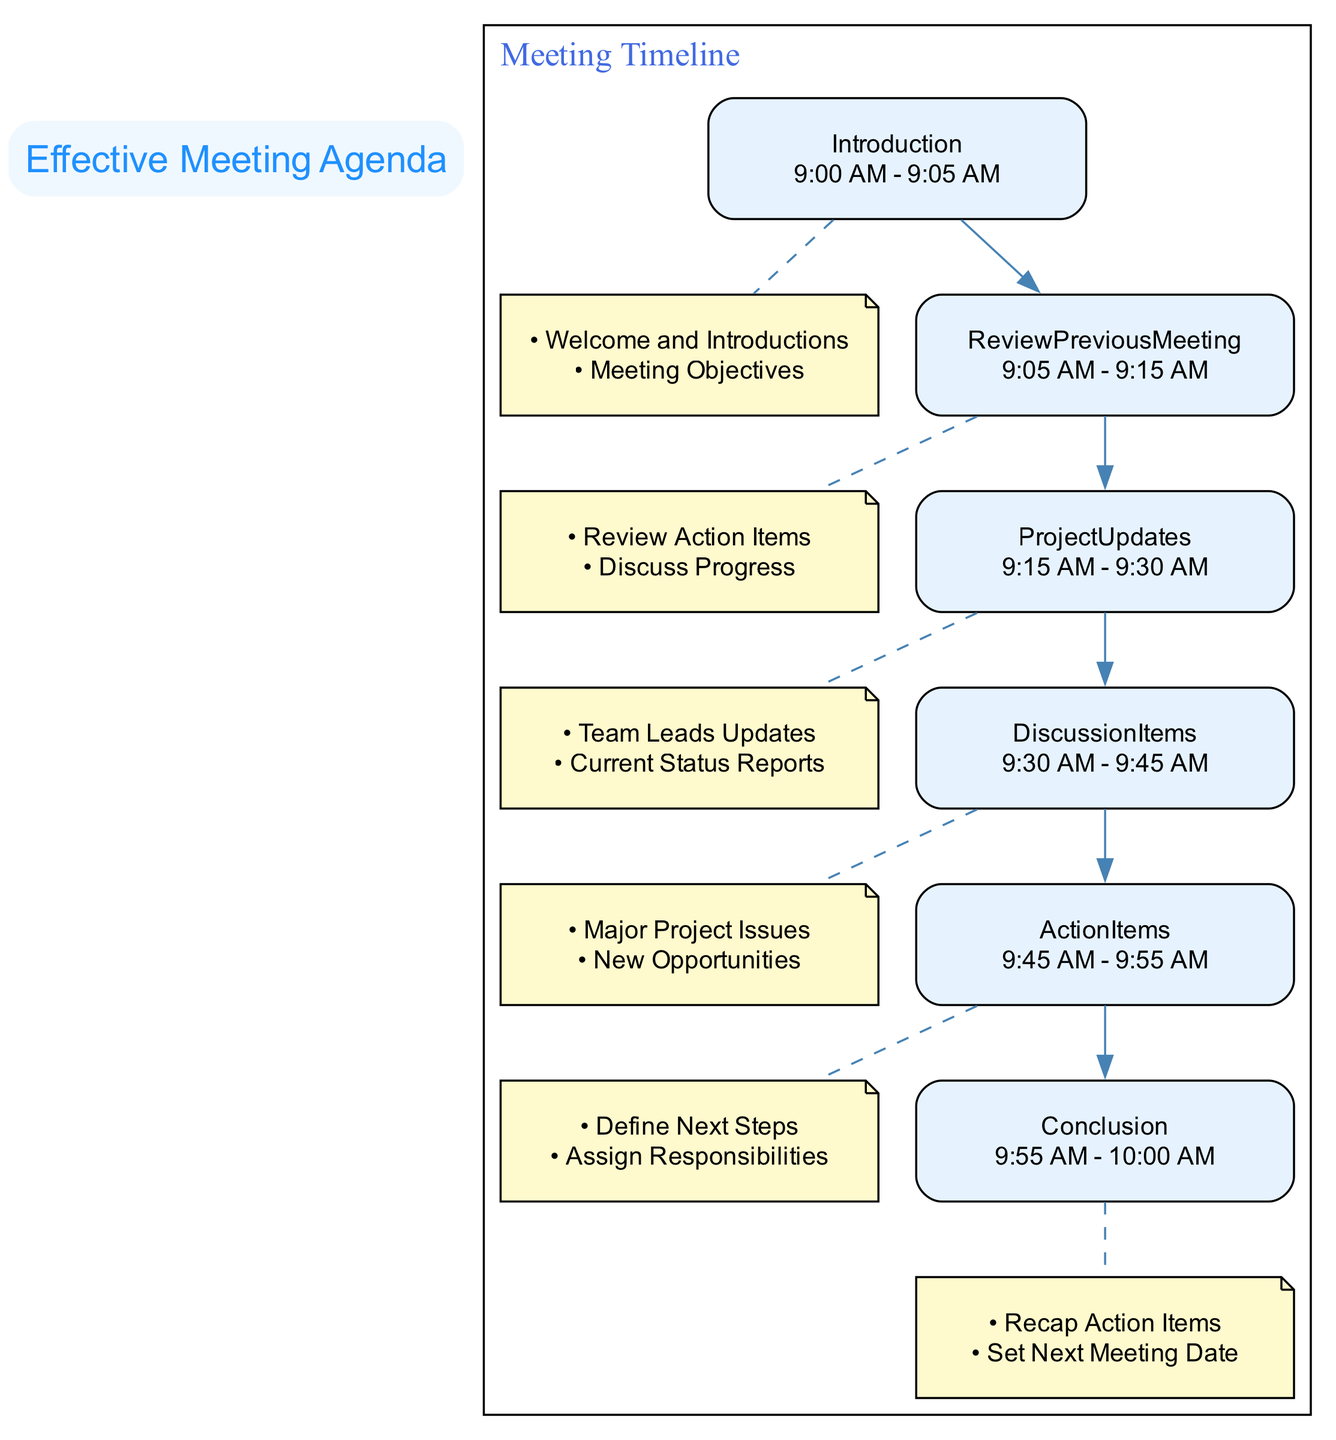What is the total duration of the meeting? The meeting starts at 9:00 AM and ends at 10:00 AM, giving a total duration of 1 hour.
Answer: 1 hour What time is allocated for Project Updates? The time allocated for Project Updates, as depicted in the diagram, is between 9:15 AM and 9:30 AM, which totals 15 minutes.
Answer: 15 minutes How many key points are discussed in the Action Items section? The Action Items section has two key points: "Define Next Steps" and "Assign Responsibilities." Therefore, there are 2 key points.
Answer: 2 Which section follows the Review Previous Meeting? After the Review Previous Meeting section, the next section displayed in the diagram is Project Updates.
Answer: Project Updates What is the last item on the agenda? The last item listed on the agenda is the Conclusion, which wraps up the meeting.
Answer: Conclusion What is the time allocated for Discussion Items? According to the diagram, the time allocated for Discussion Items is from 9:30 AM to 9:45 AM, which is 15 minutes.
Answer: 15 minutes Which key points are covered in the Introduction? The key points in the Introduction are: "Welcome and Introductions" and "Meeting Objectives."
Answer: Welcome and Introductions, Meeting Objectives What connects the Review Previous Meeting to Project Updates? The edge that connects them indicates the progression from discussing the Review Previous Meeting's outcomes to providing updates on the project.
Answer: Project Updates Name the two major elements that are summarized in the Conclusion section. The Conclusion section summarizes "Recap Action Items" and "Set Next Meeting Date."
Answer: Recap Action Items, Set Next Meeting Date 